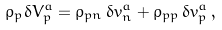Convert formula to latex. <formula><loc_0><loc_0><loc_500><loc_500>\rho _ { p } \delta V _ { p } ^ { a } = \rho _ { p n } \, \delta v _ { n } ^ { a } + \rho _ { p p } \, \delta v _ { p } ^ { a } \, ,</formula> 